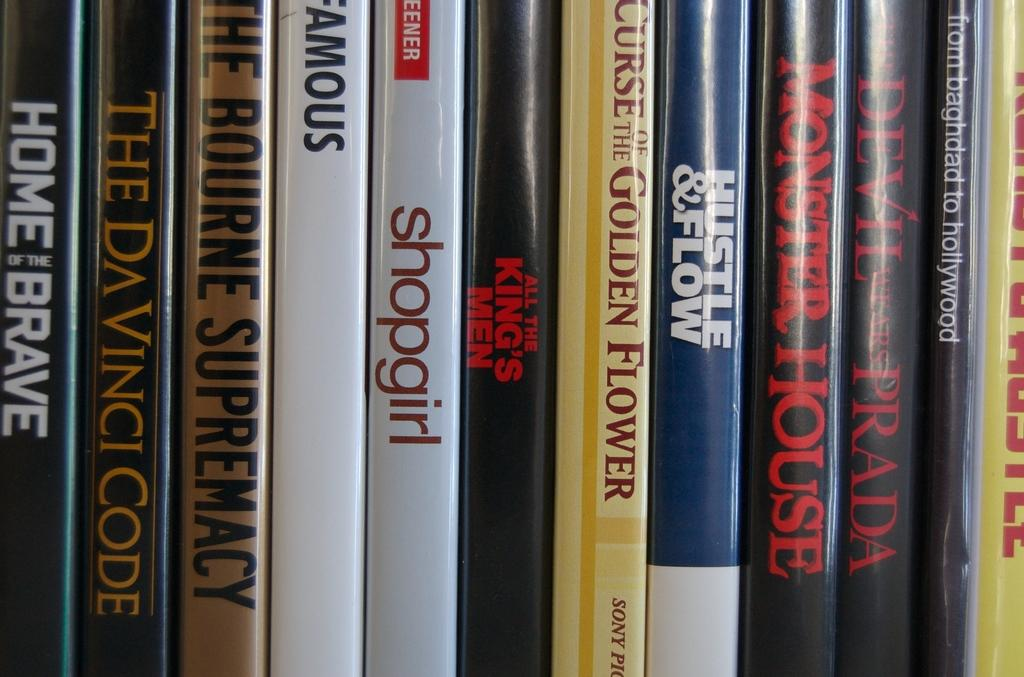Provide a one-sentence caption for the provided image. Various movies lined up on on a shelf that includes The DaVinci Code and Shopgirl. 